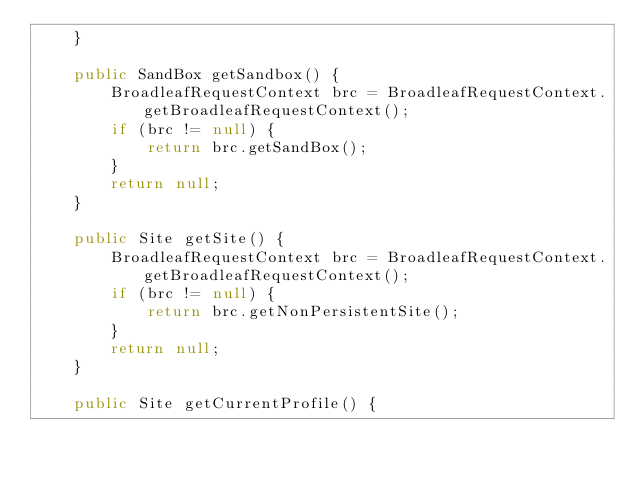<code> <loc_0><loc_0><loc_500><loc_500><_Java_>    }
    
    public SandBox getSandbox() {
        BroadleafRequestContext brc = BroadleafRequestContext.getBroadleafRequestContext();
        if (brc != null) {
            return brc.getSandBox();
        }
        return null;
    }

    public Site getSite() {
        BroadleafRequestContext brc = BroadleafRequestContext.getBroadleafRequestContext();
        if (brc != null) {
            return brc.getNonPersistentSite();
        }
        return null;
    }

    public Site getCurrentProfile() {</code> 